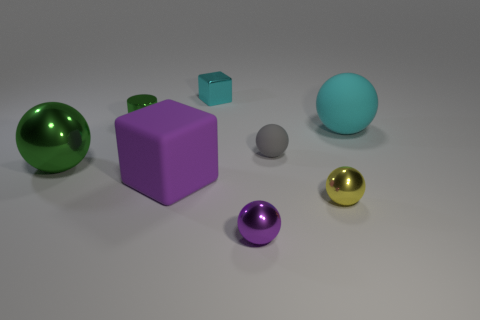Subtract all green balls. How many balls are left? 4 Subtract all yellow balls. How many balls are left? 4 Add 1 blue cubes. How many objects exist? 9 Subtract all brown balls. Subtract all blue blocks. How many balls are left? 5 Subtract all cylinders. How many objects are left? 7 Subtract all metal things. Subtract all yellow things. How many objects are left? 2 Add 2 big metal balls. How many big metal balls are left? 3 Add 8 purple metallic balls. How many purple metallic balls exist? 9 Subtract 0 yellow cylinders. How many objects are left? 8 